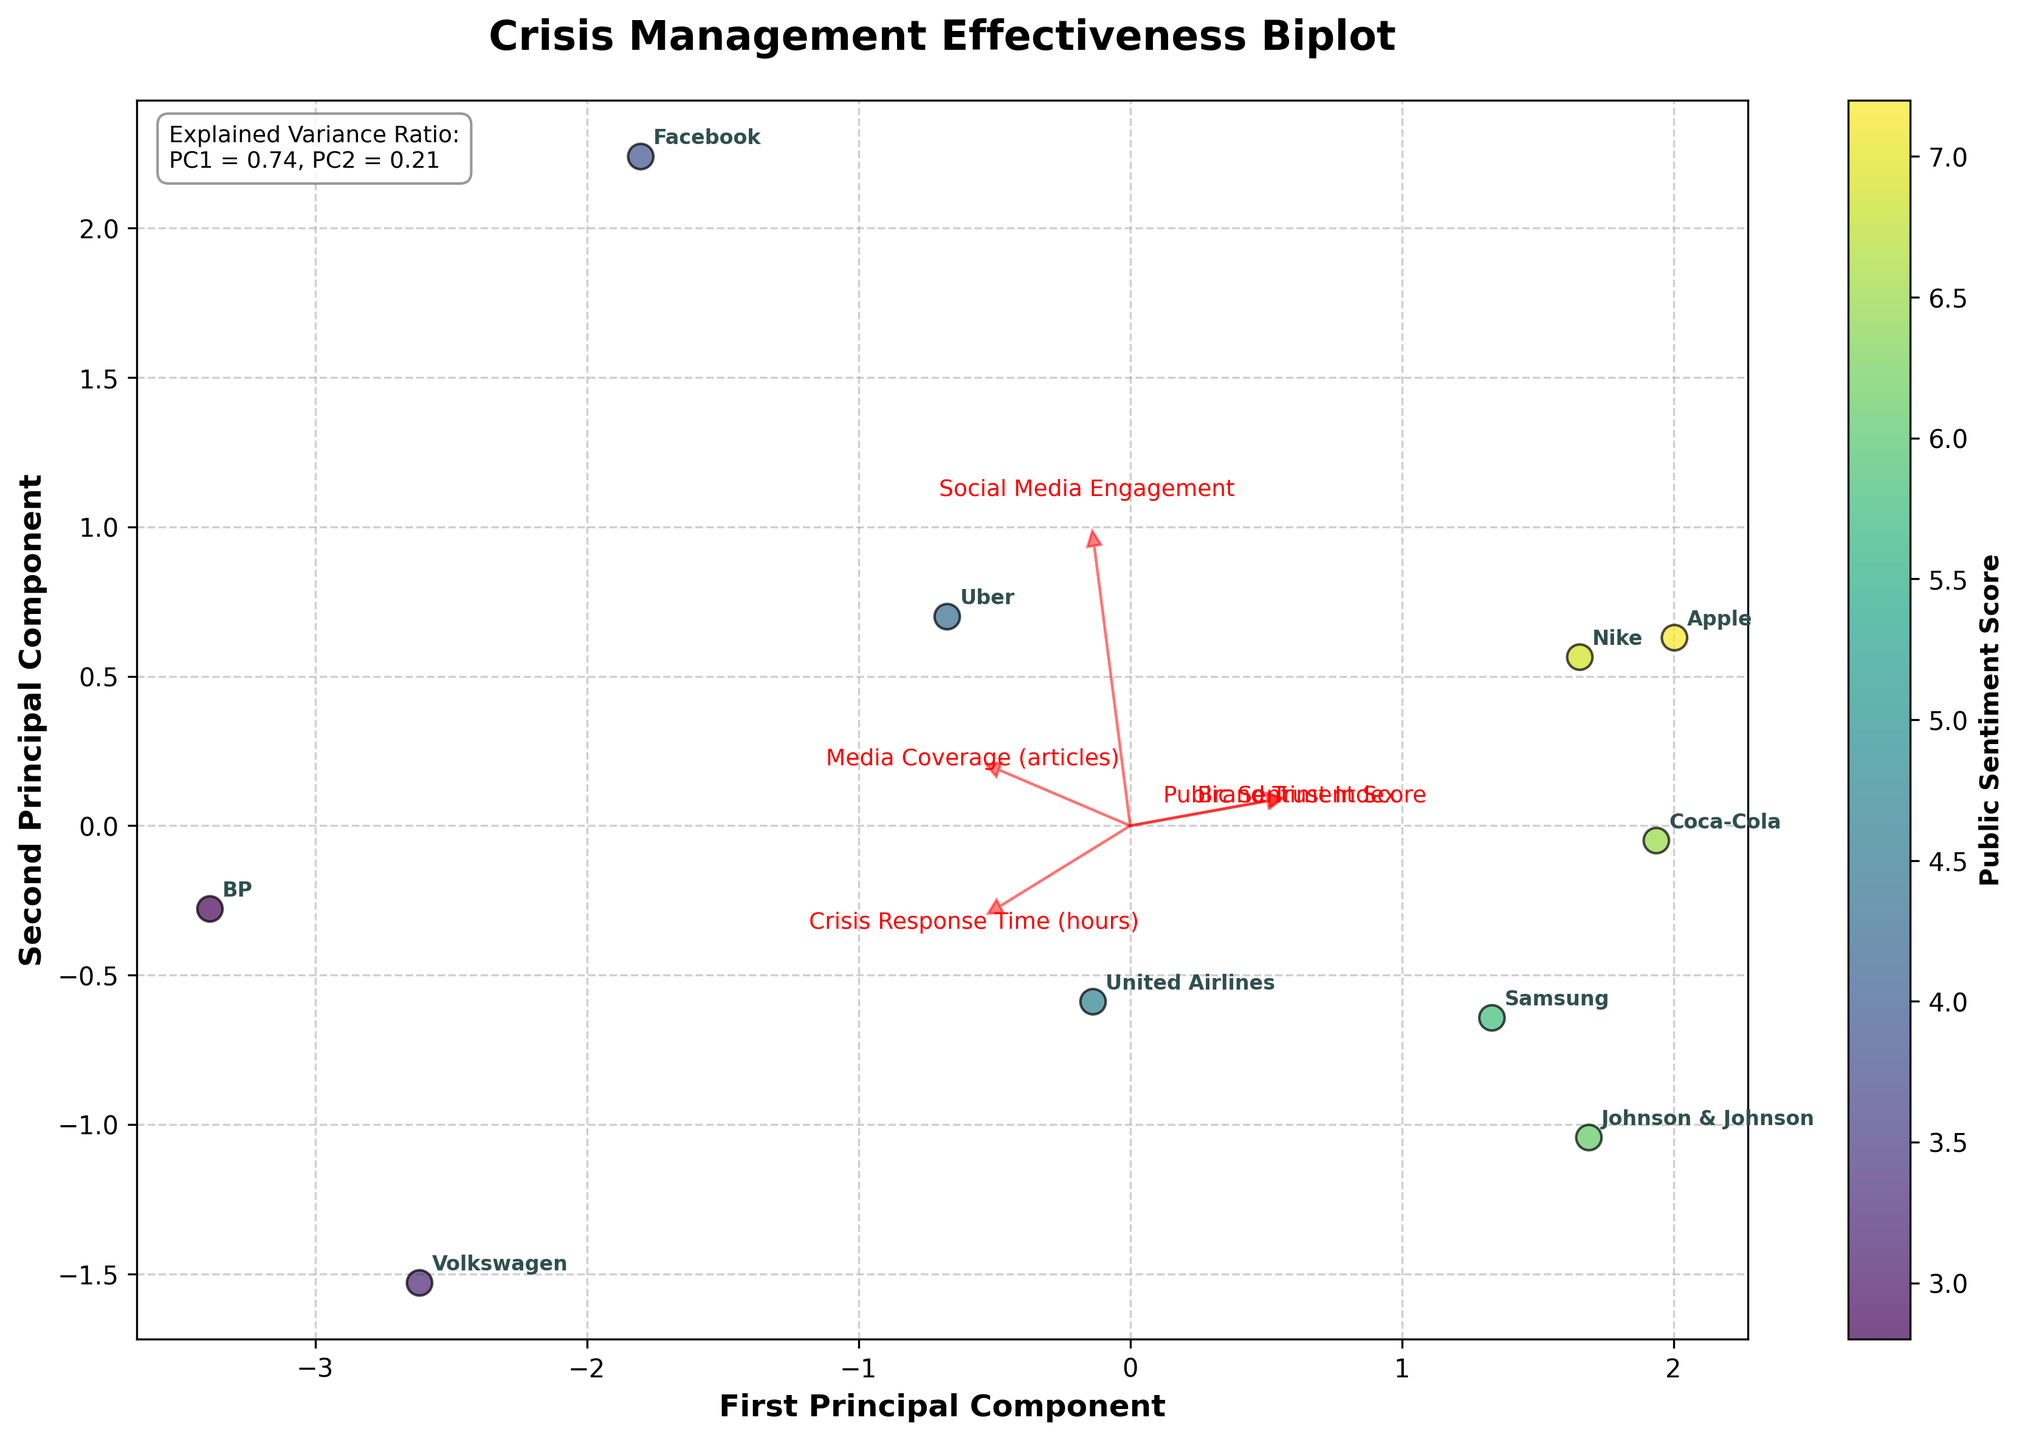What is the title of the plot? The title of the plot can generally be found at the top center of the plot. It provides an overview or subject of the plot.
Answer: Crisis Management Effectiveness Biplot How many companies are displayed in the plot? Count the number of individual data points or labelled company names in the plot.
Answer: 10 Which company has the highest Public Sentiment Score? Check the color gradient associated with each company's data point, as the color bar indicates the public sentiment score. Identify the data point with the darkest shade of green.
Answer: Apple What are the axes labeled in the plot? Look at the axis labels to understand what each principal component represents.
Answer: First Principal Component and Second Principal Component Which company has the longest Crisis Response Time? Identify the company placed furthest in the direction of the arrow labeled "Crisis Response Time (hours)" on the plot.
Answer: Volkswagen What is the explained variance ratio for the first principal component? The explained variance ratio for each principal component is mentioned as a text annotation within the plot.
Answer: 0.49 Which company has the lowest Brand Trust Index? Identify the data point whose position aligns or trends with the arrow labeled "Brand Trust Index" but in the opposite direction.
Answer: BP Name the features represented by the red arrows in the plot. The red arrows in the plot represent the features included in the PCA. Check the end of each arrow for the label.
Answer: Crisis Response Time (hours), Media Coverage (articles), Public Sentiment Score, Brand Trust Index, Social Media Engagement Which companies show higher Social Media Engagement? Identify companies placed further along the direction of the arrow labeled "Social Media Engagement" on the plot.
Answer: Facebook, Uber, Nike Compare the Media Coverage for Uber and Apple. Which one had more media coverage during the crisis? Observe the positions of Uber and Apple relative to the direction of the arrow labeled "Media Coverage (articles)." The company placed further along this arrow indicates higher coverage.
Answer: Uber 